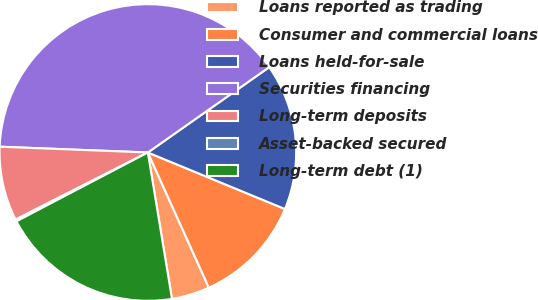<chart> <loc_0><loc_0><loc_500><loc_500><pie_chart><fcel>Loans reported as trading<fcel>Consumer and commercial loans<fcel>Loans held-for-sale<fcel>Securities financing<fcel>Long-term deposits<fcel>Asset-backed secured<fcel>Long-term debt (1)<nl><fcel>4.15%<fcel>12.03%<fcel>15.98%<fcel>39.63%<fcel>8.09%<fcel>0.21%<fcel>19.92%<nl></chart> 